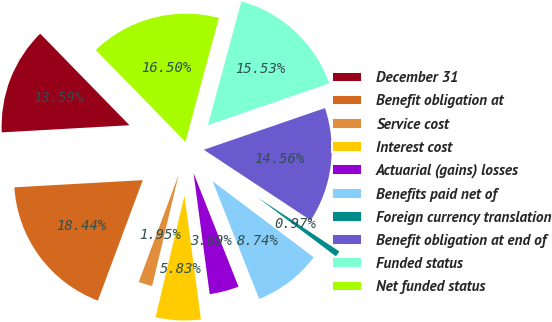<chart> <loc_0><loc_0><loc_500><loc_500><pie_chart><fcel>December 31<fcel>Benefit obligation at<fcel>Service cost<fcel>Interest cost<fcel>Actuarial (gains) losses<fcel>Benefits paid net of<fcel>Foreign currency translation<fcel>Benefit obligation at end of<fcel>Funded status<fcel>Net funded status<nl><fcel>13.59%<fcel>18.44%<fcel>1.95%<fcel>5.83%<fcel>3.89%<fcel>8.74%<fcel>0.97%<fcel>14.56%<fcel>15.53%<fcel>16.5%<nl></chart> 